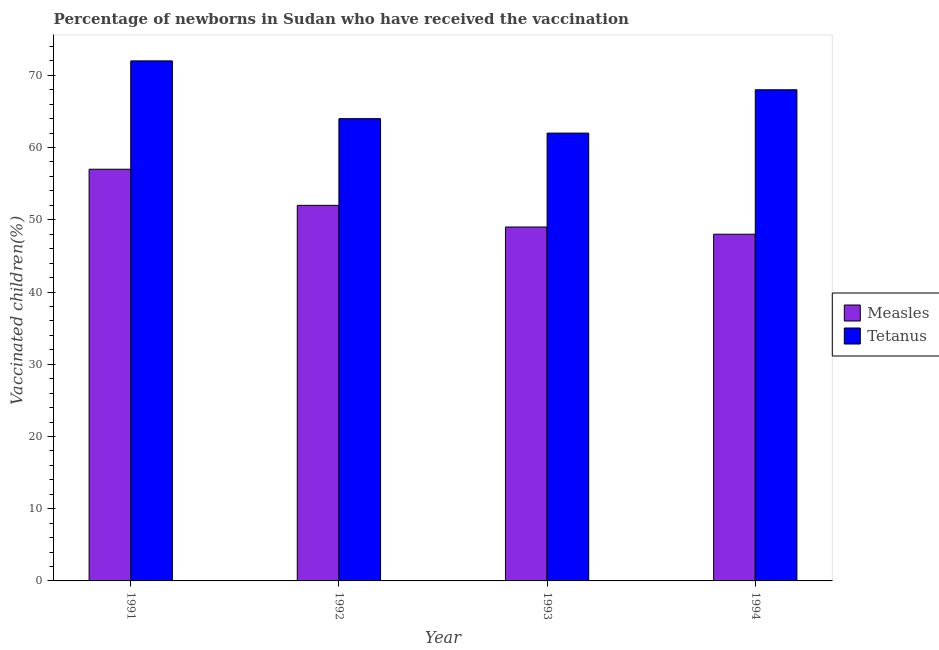How many different coloured bars are there?
Keep it short and to the point. 2. How many groups of bars are there?
Keep it short and to the point. 4. Are the number of bars on each tick of the X-axis equal?
Your answer should be compact. Yes. How many bars are there on the 4th tick from the right?
Provide a succinct answer. 2. What is the label of the 4th group of bars from the left?
Your answer should be very brief. 1994. What is the percentage of newborns who received vaccination for measles in 1991?
Your answer should be very brief. 57. Across all years, what is the maximum percentage of newborns who received vaccination for measles?
Provide a succinct answer. 57. Across all years, what is the minimum percentage of newborns who received vaccination for tetanus?
Offer a terse response. 62. What is the total percentage of newborns who received vaccination for measles in the graph?
Your answer should be very brief. 206. What is the difference between the percentage of newborns who received vaccination for measles in 1992 and that in 1993?
Make the answer very short. 3. What is the difference between the percentage of newborns who received vaccination for tetanus in 1991 and the percentage of newborns who received vaccination for measles in 1993?
Offer a terse response. 10. What is the average percentage of newborns who received vaccination for measles per year?
Your response must be concise. 51.5. In the year 1993, what is the difference between the percentage of newborns who received vaccination for tetanus and percentage of newborns who received vaccination for measles?
Give a very brief answer. 0. In how many years, is the percentage of newborns who received vaccination for measles greater than 4 %?
Your answer should be compact. 4. What is the ratio of the percentage of newborns who received vaccination for measles in 1993 to that in 1994?
Give a very brief answer. 1.02. Is the percentage of newborns who received vaccination for measles in 1991 less than that in 1992?
Your answer should be compact. No. What is the difference between the highest and the second highest percentage of newborns who received vaccination for tetanus?
Make the answer very short. 4. What is the difference between the highest and the lowest percentage of newborns who received vaccination for tetanus?
Ensure brevity in your answer.  10. In how many years, is the percentage of newborns who received vaccination for tetanus greater than the average percentage of newborns who received vaccination for tetanus taken over all years?
Your answer should be very brief. 2. What does the 1st bar from the left in 1991 represents?
Offer a very short reply. Measles. What does the 1st bar from the right in 1991 represents?
Your answer should be compact. Tetanus. Are all the bars in the graph horizontal?
Ensure brevity in your answer.  No. How many years are there in the graph?
Your answer should be compact. 4. Are the values on the major ticks of Y-axis written in scientific E-notation?
Offer a very short reply. No. Does the graph contain grids?
Give a very brief answer. No. Where does the legend appear in the graph?
Your response must be concise. Center right. How many legend labels are there?
Make the answer very short. 2. What is the title of the graph?
Your answer should be compact. Percentage of newborns in Sudan who have received the vaccination. What is the label or title of the Y-axis?
Give a very brief answer. Vaccinated children(%)
. What is the Vaccinated children(%)
 of Measles in 1991?
Offer a very short reply. 57. What is the Vaccinated children(%)
 of Tetanus in 1991?
Ensure brevity in your answer.  72. What is the Vaccinated children(%)
 in Tetanus in 1992?
Your answer should be very brief. 64. What is the Vaccinated children(%)
 of Tetanus in 1994?
Give a very brief answer. 68. Across all years, what is the maximum Vaccinated children(%)
 in Tetanus?
Your answer should be compact. 72. What is the total Vaccinated children(%)
 in Measles in the graph?
Keep it short and to the point. 206. What is the total Vaccinated children(%)
 in Tetanus in the graph?
Give a very brief answer. 266. What is the difference between the Vaccinated children(%)
 of Tetanus in 1991 and that in 1992?
Offer a terse response. 8. What is the difference between the Vaccinated children(%)
 in Measles in 1991 and that in 1993?
Keep it short and to the point. 8. What is the difference between the Vaccinated children(%)
 in Measles in 1992 and that in 1993?
Make the answer very short. 3. What is the difference between the Vaccinated children(%)
 in Tetanus in 1992 and that in 1993?
Your answer should be compact. 2. What is the difference between the Vaccinated children(%)
 of Measles in 1992 and that in 1994?
Keep it short and to the point. 4. What is the difference between the Vaccinated children(%)
 of Tetanus in 1992 and that in 1994?
Your answer should be compact. -4. What is the difference between the Vaccinated children(%)
 in Measles in 1993 and that in 1994?
Make the answer very short. 1. What is the difference between the Vaccinated children(%)
 of Tetanus in 1993 and that in 1994?
Your answer should be compact. -6. What is the difference between the Vaccinated children(%)
 of Measles in 1991 and the Vaccinated children(%)
 of Tetanus in 1992?
Ensure brevity in your answer.  -7. What is the difference between the Vaccinated children(%)
 of Measles in 1992 and the Vaccinated children(%)
 of Tetanus in 1994?
Give a very brief answer. -16. What is the average Vaccinated children(%)
 of Measles per year?
Ensure brevity in your answer.  51.5. What is the average Vaccinated children(%)
 in Tetanus per year?
Provide a succinct answer. 66.5. What is the ratio of the Vaccinated children(%)
 of Measles in 1991 to that in 1992?
Provide a short and direct response. 1.1. What is the ratio of the Vaccinated children(%)
 in Measles in 1991 to that in 1993?
Your answer should be compact. 1.16. What is the ratio of the Vaccinated children(%)
 in Tetanus in 1991 to that in 1993?
Provide a succinct answer. 1.16. What is the ratio of the Vaccinated children(%)
 in Measles in 1991 to that in 1994?
Make the answer very short. 1.19. What is the ratio of the Vaccinated children(%)
 of Tetanus in 1991 to that in 1994?
Your answer should be compact. 1.06. What is the ratio of the Vaccinated children(%)
 of Measles in 1992 to that in 1993?
Provide a succinct answer. 1.06. What is the ratio of the Vaccinated children(%)
 in Tetanus in 1992 to that in 1993?
Keep it short and to the point. 1.03. What is the ratio of the Vaccinated children(%)
 in Measles in 1993 to that in 1994?
Offer a terse response. 1.02. What is the ratio of the Vaccinated children(%)
 in Tetanus in 1993 to that in 1994?
Make the answer very short. 0.91. What is the difference between the highest and the second highest Vaccinated children(%)
 of Tetanus?
Offer a terse response. 4. 